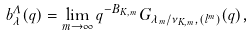<formula> <loc_0><loc_0><loc_500><loc_500>b ^ { \Lambda } _ { \lambda } ( q ) = \lim _ { m \to \infty } q ^ { - B _ { K , m } } G _ { \lambda _ { m } / \nu _ { K , m } , ( l ^ { m } ) } ( q ) ,</formula> 